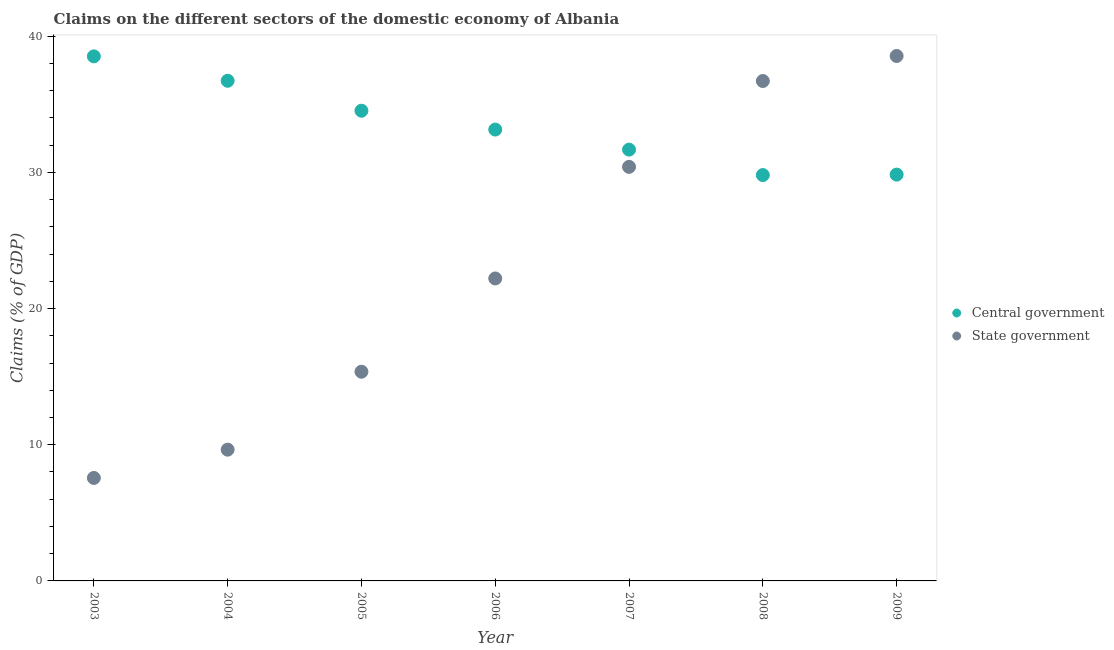How many different coloured dotlines are there?
Keep it short and to the point. 2. What is the claims on state government in 2005?
Ensure brevity in your answer.  15.36. Across all years, what is the maximum claims on central government?
Ensure brevity in your answer.  38.52. Across all years, what is the minimum claims on central government?
Your answer should be very brief. 29.8. In which year was the claims on central government maximum?
Make the answer very short. 2003. What is the total claims on central government in the graph?
Offer a very short reply. 234.22. What is the difference between the claims on state government in 2008 and that in 2009?
Make the answer very short. -1.84. What is the difference between the claims on state government in 2006 and the claims on central government in 2009?
Offer a terse response. -7.62. What is the average claims on state government per year?
Your answer should be very brief. 22.92. In the year 2009, what is the difference between the claims on state government and claims on central government?
Provide a succinct answer. 8.71. In how many years, is the claims on central government greater than 28 %?
Your answer should be compact. 7. What is the ratio of the claims on state government in 2005 to that in 2007?
Provide a succinct answer. 0.51. Is the claims on central government in 2007 less than that in 2009?
Provide a succinct answer. No. Is the difference between the claims on state government in 2004 and 2006 greater than the difference between the claims on central government in 2004 and 2006?
Your answer should be very brief. No. What is the difference between the highest and the second highest claims on state government?
Provide a short and direct response. 1.84. What is the difference between the highest and the lowest claims on central government?
Provide a short and direct response. 8.72. How many dotlines are there?
Your answer should be compact. 2. What is the difference between two consecutive major ticks on the Y-axis?
Offer a terse response. 10. Where does the legend appear in the graph?
Offer a terse response. Center right. How many legend labels are there?
Your answer should be compact. 2. How are the legend labels stacked?
Make the answer very short. Vertical. What is the title of the graph?
Provide a short and direct response. Claims on the different sectors of the domestic economy of Albania. Does "Export" appear as one of the legend labels in the graph?
Make the answer very short. No. What is the label or title of the X-axis?
Offer a terse response. Year. What is the label or title of the Y-axis?
Give a very brief answer. Claims (% of GDP). What is the Claims (% of GDP) in Central government in 2003?
Make the answer very short. 38.52. What is the Claims (% of GDP) of State government in 2003?
Offer a very short reply. 7.56. What is the Claims (% of GDP) of Central government in 2004?
Provide a short and direct response. 36.73. What is the Claims (% of GDP) in State government in 2004?
Your answer should be compact. 9.64. What is the Claims (% of GDP) of Central government in 2005?
Offer a terse response. 34.53. What is the Claims (% of GDP) in State government in 2005?
Make the answer very short. 15.36. What is the Claims (% of GDP) in Central government in 2006?
Offer a terse response. 33.14. What is the Claims (% of GDP) of State government in 2006?
Give a very brief answer. 22.21. What is the Claims (% of GDP) in Central government in 2007?
Offer a terse response. 31.67. What is the Claims (% of GDP) of State government in 2007?
Keep it short and to the point. 30.41. What is the Claims (% of GDP) of Central government in 2008?
Your response must be concise. 29.8. What is the Claims (% of GDP) of State government in 2008?
Give a very brief answer. 36.71. What is the Claims (% of GDP) in Central government in 2009?
Your response must be concise. 29.83. What is the Claims (% of GDP) of State government in 2009?
Provide a succinct answer. 38.55. Across all years, what is the maximum Claims (% of GDP) of Central government?
Provide a succinct answer. 38.52. Across all years, what is the maximum Claims (% of GDP) of State government?
Provide a short and direct response. 38.55. Across all years, what is the minimum Claims (% of GDP) in Central government?
Provide a succinct answer. 29.8. Across all years, what is the minimum Claims (% of GDP) of State government?
Your answer should be very brief. 7.56. What is the total Claims (% of GDP) in Central government in the graph?
Offer a terse response. 234.22. What is the total Claims (% of GDP) in State government in the graph?
Your answer should be compact. 160.43. What is the difference between the Claims (% of GDP) in Central government in 2003 and that in 2004?
Make the answer very short. 1.79. What is the difference between the Claims (% of GDP) of State government in 2003 and that in 2004?
Offer a very short reply. -2.08. What is the difference between the Claims (% of GDP) of Central government in 2003 and that in 2005?
Your answer should be very brief. 3.99. What is the difference between the Claims (% of GDP) in State government in 2003 and that in 2005?
Provide a short and direct response. -7.8. What is the difference between the Claims (% of GDP) of Central government in 2003 and that in 2006?
Provide a succinct answer. 5.38. What is the difference between the Claims (% of GDP) of State government in 2003 and that in 2006?
Provide a succinct answer. -14.65. What is the difference between the Claims (% of GDP) in Central government in 2003 and that in 2007?
Keep it short and to the point. 6.85. What is the difference between the Claims (% of GDP) of State government in 2003 and that in 2007?
Provide a short and direct response. -22.84. What is the difference between the Claims (% of GDP) of Central government in 2003 and that in 2008?
Make the answer very short. 8.72. What is the difference between the Claims (% of GDP) in State government in 2003 and that in 2008?
Keep it short and to the point. -29.15. What is the difference between the Claims (% of GDP) in Central government in 2003 and that in 2009?
Your response must be concise. 8.68. What is the difference between the Claims (% of GDP) of State government in 2003 and that in 2009?
Ensure brevity in your answer.  -30.99. What is the difference between the Claims (% of GDP) of Central government in 2004 and that in 2005?
Your answer should be compact. 2.2. What is the difference between the Claims (% of GDP) in State government in 2004 and that in 2005?
Make the answer very short. -5.72. What is the difference between the Claims (% of GDP) in Central government in 2004 and that in 2006?
Ensure brevity in your answer.  3.58. What is the difference between the Claims (% of GDP) of State government in 2004 and that in 2006?
Keep it short and to the point. -12.57. What is the difference between the Claims (% of GDP) in Central government in 2004 and that in 2007?
Offer a terse response. 5.05. What is the difference between the Claims (% of GDP) in State government in 2004 and that in 2007?
Your response must be concise. -20.77. What is the difference between the Claims (% of GDP) of Central government in 2004 and that in 2008?
Your answer should be very brief. 6.92. What is the difference between the Claims (% of GDP) of State government in 2004 and that in 2008?
Your response must be concise. -27.07. What is the difference between the Claims (% of GDP) in Central government in 2004 and that in 2009?
Offer a terse response. 6.89. What is the difference between the Claims (% of GDP) of State government in 2004 and that in 2009?
Make the answer very short. -28.91. What is the difference between the Claims (% of GDP) in Central government in 2005 and that in 2006?
Your answer should be very brief. 1.38. What is the difference between the Claims (% of GDP) of State government in 2005 and that in 2006?
Your answer should be compact. -6.85. What is the difference between the Claims (% of GDP) of Central government in 2005 and that in 2007?
Offer a very short reply. 2.86. What is the difference between the Claims (% of GDP) of State government in 2005 and that in 2007?
Ensure brevity in your answer.  -15.04. What is the difference between the Claims (% of GDP) in Central government in 2005 and that in 2008?
Offer a very short reply. 4.72. What is the difference between the Claims (% of GDP) in State government in 2005 and that in 2008?
Your answer should be very brief. -21.35. What is the difference between the Claims (% of GDP) in Central government in 2005 and that in 2009?
Give a very brief answer. 4.69. What is the difference between the Claims (% of GDP) of State government in 2005 and that in 2009?
Your answer should be very brief. -23.19. What is the difference between the Claims (% of GDP) of Central government in 2006 and that in 2007?
Give a very brief answer. 1.47. What is the difference between the Claims (% of GDP) of State government in 2006 and that in 2007?
Your response must be concise. -8.19. What is the difference between the Claims (% of GDP) in Central government in 2006 and that in 2008?
Offer a terse response. 3.34. What is the difference between the Claims (% of GDP) of State government in 2006 and that in 2008?
Your response must be concise. -14.5. What is the difference between the Claims (% of GDP) in Central government in 2006 and that in 2009?
Give a very brief answer. 3.31. What is the difference between the Claims (% of GDP) in State government in 2006 and that in 2009?
Provide a succinct answer. -16.34. What is the difference between the Claims (% of GDP) of Central government in 2007 and that in 2008?
Ensure brevity in your answer.  1.87. What is the difference between the Claims (% of GDP) in State government in 2007 and that in 2008?
Offer a terse response. -6.3. What is the difference between the Claims (% of GDP) of Central government in 2007 and that in 2009?
Provide a succinct answer. 1.84. What is the difference between the Claims (% of GDP) in State government in 2007 and that in 2009?
Your answer should be very brief. -8.14. What is the difference between the Claims (% of GDP) in Central government in 2008 and that in 2009?
Offer a terse response. -0.03. What is the difference between the Claims (% of GDP) in State government in 2008 and that in 2009?
Your answer should be compact. -1.84. What is the difference between the Claims (% of GDP) in Central government in 2003 and the Claims (% of GDP) in State government in 2004?
Offer a very short reply. 28.88. What is the difference between the Claims (% of GDP) in Central government in 2003 and the Claims (% of GDP) in State government in 2005?
Offer a terse response. 23.16. What is the difference between the Claims (% of GDP) in Central government in 2003 and the Claims (% of GDP) in State government in 2006?
Keep it short and to the point. 16.31. What is the difference between the Claims (% of GDP) in Central government in 2003 and the Claims (% of GDP) in State government in 2007?
Provide a succinct answer. 8.11. What is the difference between the Claims (% of GDP) of Central government in 2003 and the Claims (% of GDP) of State government in 2008?
Provide a succinct answer. 1.81. What is the difference between the Claims (% of GDP) of Central government in 2003 and the Claims (% of GDP) of State government in 2009?
Ensure brevity in your answer.  -0.03. What is the difference between the Claims (% of GDP) of Central government in 2004 and the Claims (% of GDP) of State government in 2005?
Your answer should be compact. 21.36. What is the difference between the Claims (% of GDP) of Central government in 2004 and the Claims (% of GDP) of State government in 2006?
Ensure brevity in your answer.  14.51. What is the difference between the Claims (% of GDP) in Central government in 2004 and the Claims (% of GDP) in State government in 2007?
Ensure brevity in your answer.  6.32. What is the difference between the Claims (% of GDP) in Central government in 2004 and the Claims (% of GDP) in State government in 2008?
Your response must be concise. 0.02. What is the difference between the Claims (% of GDP) in Central government in 2004 and the Claims (% of GDP) in State government in 2009?
Make the answer very short. -1.82. What is the difference between the Claims (% of GDP) of Central government in 2005 and the Claims (% of GDP) of State government in 2006?
Keep it short and to the point. 12.32. What is the difference between the Claims (% of GDP) in Central government in 2005 and the Claims (% of GDP) in State government in 2007?
Offer a terse response. 4.12. What is the difference between the Claims (% of GDP) in Central government in 2005 and the Claims (% of GDP) in State government in 2008?
Your response must be concise. -2.18. What is the difference between the Claims (% of GDP) of Central government in 2005 and the Claims (% of GDP) of State government in 2009?
Give a very brief answer. -4.02. What is the difference between the Claims (% of GDP) in Central government in 2006 and the Claims (% of GDP) in State government in 2007?
Your answer should be compact. 2.74. What is the difference between the Claims (% of GDP) in Central government in 2006 and the Claims (% of GDP) in State government in 2008?
Your response must be concise. -3.57. What is the difference between the Claims (% of GDP) in Central government in 2006 and the Claims (% of GDP) in State government in 2009?
Your answer should be compact. -5.4. What is the difference between the Claims (% of GDP) in Central government in 2007 and the Claims (% of GDP) in State government in 2008?
Make the answer very short. -5.04. What is the difference between the Claims (% of GDP) in Central government in 2007 and the Claims (% of GDP) in State government in 2009?
Your answer should be very brief. -6.88. What is the difference between the Claims (% of GDP) of Central government in 2008 and the Claims (% of GDP) of State government in 2009?
Provide a short and direct response. -8.75. What is the average Claims (% of GDP) in Central government per year?
Your answer should be compact. 33.46. What is the average Claims (% of GDP) of State government per year?
Ensure brevity in your answer.  22.92. In the year 2003, what is the difference between the Claims (% of GDP) in Central government and Claims (% of GDP) in State government?
Offer a very short reply. 30.96. In the year 2004, what is the difference between the Claims (% of GDP) in Central government and Claims (% of GDP) in State government?
Provide a succinct answer. 27.09. In the year 2005, what is the difference between the Claims (% of GDP) of Central government and Claims (% of GDP) of State government?
Your response must be concise. 19.17. In the year 2006, what is the difference between the Claims (% of GDP) in Central government and Claims (% of GDP) in State government?
Provide a succinct answer. 10.93. In the year 2007, what is the difference between the Claims (% of GDP) of Central government and Claims (% of GDP) of State government?
Your answer should be very brief. 1.27. In the year 2008, what is the difference between the Claims (% of GDP) of Central government and Claims (% of GDP) of State government?
Ensure brevity in your answer.  -6.91. In the year 2009, what is the difference between the Claims (% of GDP) of Central government and Claims (% of GDP) of State government?
Your response must be concise. -8.71. What is the ratio of the Claims (% of GDP) of Central government in 2003 to that in 2004?
Give a very brief answer. 1.05. What is the ratio of the Claims (% of GDP) in State government in 2003 to that in 2004?
Keep it short and to the point. 0.78. What is the ratio of the Claims (% of GDP) in Central government in 2003 to that in 2005?
Ensure brevity in your answer.  1.12. What is the ratio of the Claims (% of GDP) of State government in 2003 to that in 2005?
Ensure brevity in your answer.  0.49. What is the ratio of the Claims (% of GDP) in Central government in 2003 to that in 2006?
Ensure brevity in your answer.  1.16. What is the ratio of the Claims (% of GDP) of State government in 2003 to that in 2006?
Offer a very short reply. 0.34. What is the ratio of the Claims (% of GDP) in Central government in 2003 to that in 2007?
Offer a very short reply. 1.22. What is the ratio of the Claims (% of GDP) in State government in 2003 to that in 2007?
Your answer should be compact. 0.25. What is the ratio of the Claims (% of GDP) in Central government in 2003 to that in 2008?
Provide a succinct answer. 1.29. What is the ratio of the Claims (% of GDP) in State government in 2003 to that in 2008?
Offer a terse response. 0.21. What is the ratio of the Claims (% of GDP) in Central government in 2003 to that in 2009?
Your response must be concise. 1.29. What is the ratio of the Claims (% of GDP) of State government in 2003 to that in 2009?
Your answer should be very brief. 0.2. What is the ratio of the Claims (% of GDP) in Central government in 2004 to that in 2005?
Your answer should be very brief. 1.06. What is the ratio of the Claims (% of GDP) in State government in 2004 to that in 2005?
Ensure brevity in your answer.  0.63. What is the ratio of the Claims (% of GDP) of Central government in 2004 to that in 2006?
Provide a short and direct response. 1.11. What is the ratio of the Claims (% of GDP) of State government in 2004 to that in 2006?
Provide a succinct answer. 0.43. What is the ratio of the Claims (% of GDP) of Central government in 2004 to that in 2007?
Your answer should be compact. 1.16. What is the ratio of the Claims (% of GDP) in State government in 2004 to that in 2007?
Keep it short and to the point. 0.32. What is the ratio of the Claims (% of GDP) in Central government in 2004 to that in 2008?
Make the answer very short. 1.23. What is the ratio of the Claims (% of GDP) in State government in 2004 to that in 2008?
Give a very brief answer. 0.26. What is the ratio of the Claims (% of GDP) in Central government in 2004 to that in 2009?
Ensure brevity in your answer.  1.23. What is the ratio of the Claims (% of GDP) of Central government in 2005 to that in 2006?
Keep it short and to the point. 1.04. What is the ratio of the Claims (% of GDP) of State government in 2005 to that in 2006?
Your answer should be very brief. 0.69. What is the ratio of the Claims (% of GDP) of Central government in 2005 to that in 2007?
Ensure brevity in your answer.  1.09. What is the ratio of the Claims (% of GDP) in State government in 2005 to that in 2007?
Make the answer very short. 0.51. What is the ratio of the Claims (% of GDP) of Central government in 2005 to that in 2008?
Make the answer very short. 1.16. What is the ratio of the Claims (% of GDP) of State government in 2005 to that in 2008?
Provide a short and direct response. 0.42. What is the ratio of the Claims (% of GDP) in Central government in 2005 to that in 2009?
Give a very brief answer. 1.16. What is the ratio of the Claims (% of GDP) of State government in 2005 to that in 2009?
Provide a short and direct response. 0.4. What is the ratio of the Claims (% of GDP) in Central government in 2006 to that in 2007?
Ensure brevity in your answer.  1.05. What is the ratio of the Claims (% of GDP) of State government in 2006 to that in 2007?
Make the answer very short. 0.73. What is the ratio of the Claims (% of GDP) of Central government in 2006 to that in 2008?
Offer a very short reply. 1.11. What is the ratio of the Claims (% of GDP) in State government in 2006 to that in 2008?
Your answer should be very brief. 0.6. What is the ratio of the Claims (% of GDP) in Central government in 2006 to that in 2009?
Your answer should be very brief. 1.11. What is the ratio of the Claims (% of GDP) of State government in 2006 to that in 2009?
Your response must be concise. 0.58. What is the ratio of the Claims (% of GDP) of Central government in 2007 to that in 2008?
Keep it short and to the point. 1.06. What is the ratio of the Claims (% of GDP) of State government in 2007 to that in 2008?
Keep it short and to the point. 0.83. What is the ratio of the Claims (% of GDP) in Central government in 2007 to that in 2009?
Provide a short and direct response. 1.06. What is the ratio of the Claims (% of GDP) in State government in 2007 to that in 2009?
Offer a terse response. 0.79. What is the ratio of the Claims (% of GDP) of State government in 2008 to that in 2009?
Offer a very short reply. 0.95. What is the difference between the highest and the second highest Claims (% of GDP) of Central government?
Your response must be concise. 1.79. What is the difference between the highest and the second highest Claims (% of GDP) in State government?
Make the answer very short. 1.84. What is the difference between the highest and the lowest Claims (% of GDP) of Central government?
Your answer should be compact. 8.72. What is the difference between the highest and the lowest Claims (% of GDP) of State government?
Provide a short and direct response. 30.99. 